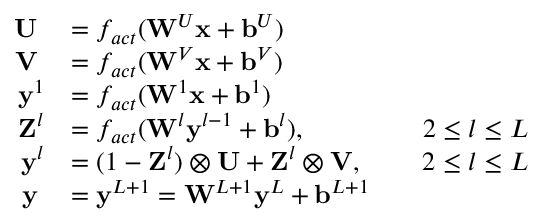Convert formula to latex. <formula><loc_0><loc_0><loc_500><loc_500>\begin{array} { r l r l } { U \, } & { = f _ { a c t } ( W ^ { U } x + b ^ { U } ) } & \\ { V \, } & { = f _ { a c t } ( W ^ { V } x + b ^ { V } ) } & \\ { y ^ { 1 } } & { = f _ { a c t } ( W ^ { 1 } x + b ^ { 1 } ) } & \\ { Z ^ { l } } & { = f _ { a c t } ( W ^ { l } y ^ { l - 1 } + b ^ { l } ) , } & & { 2 \leq l \leq L } \\ { y ^ { l } } & { = ( 1 - Z ^ { l } ) \otimes U + Z ^ { l } \otimes V , } & & { 2 \leq l \leq L } \\ { y \, } & { = y ^ { L + 1 } = W ^ { L + 1 } y ^ { L } + b ^ { L + 1 } } & \end{array}</formula> 